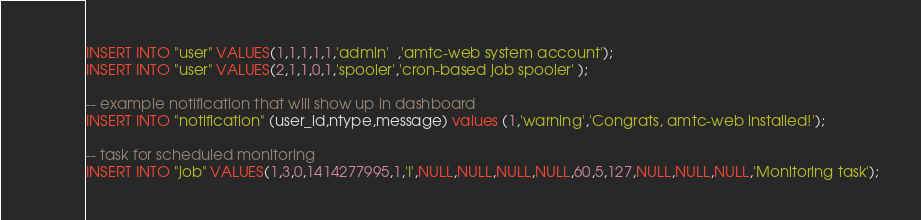<code> <loc_0><loc_0><loc_500><loc_500><_SQL_>INSERT INTO "user" VALUES(1,1,1,1,1,'admin'  ,'amtc-web system account');
INSERT INTO "user" VALUES(2,1,1,0,1,'spooler','cron-based job spooler' );

-- example notification that will show up in dashboard
INSERT INTO "notification" (user_id,ntype,message) values (1,'warning','Congrats, amtc-web installed!');

-- task for scheduled monitoring
INSERT INTO "job" VALUES(1,3,0,1414277995,1,'I',NULL,NULL,NULL,NULL,60,5,127,NULL,NULL,NULL,'Monitoring task');
</code> 